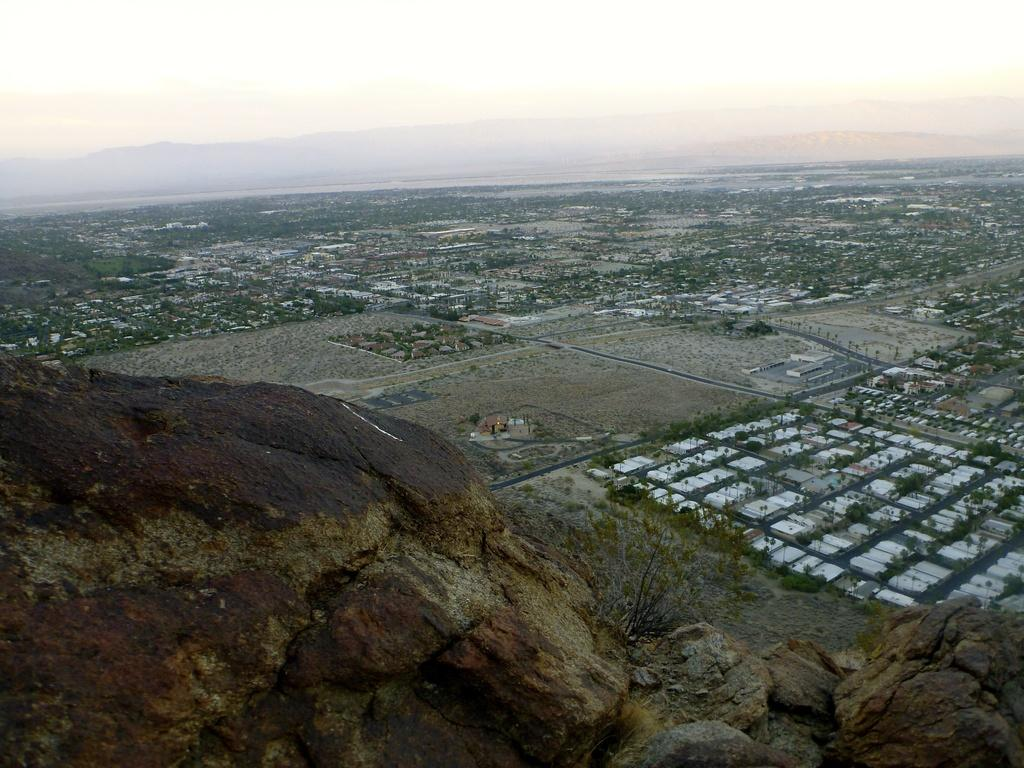What is located in the front of the image? There are rocks in the front of the image. What can be seen in the background of the image? There are buildings and trees in the background of the image. What is visible at the top of the image? The sky is visible at the top of the image. Can you tell me how many giraffes are visible in the image? There are no giraffes present in the image. What type of shoe is shown on the rocks in the image? There are no shoes present in the image; it features rocks, buildings, trees, and the sky. 